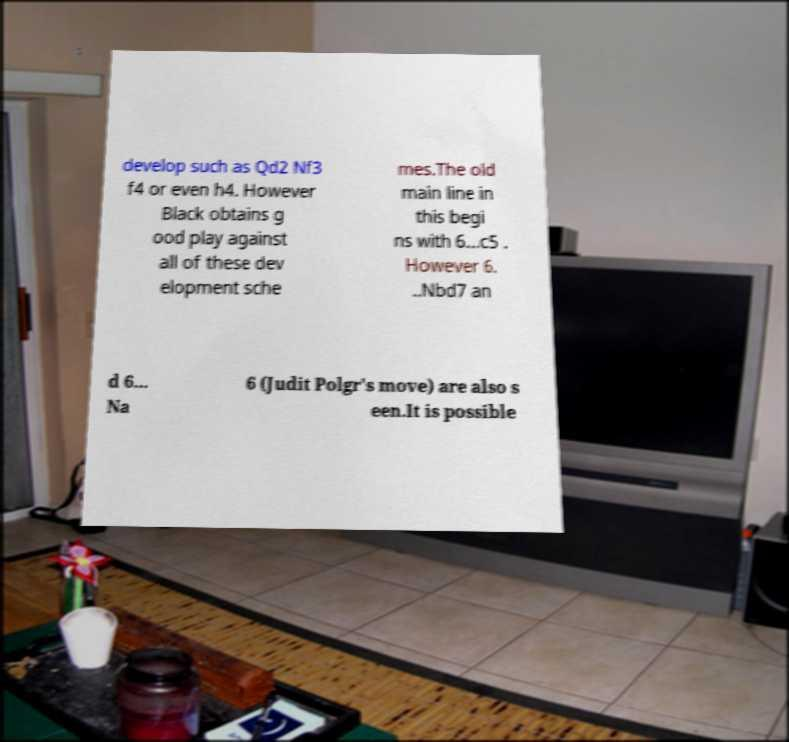Can you read and provide the text displayed in the image?This photo seems to have some interesting text. Can you extract and type it out for me? develop such as Qd2 Nf3 f4 or even h4. However Black obtains g ood play against all of these dev elopment sche mes.The old main line in this begi ns with 6...c5 . However 6. ..Nbd7 an d 6... Na 6 (Judit Polgr's move) are also s een.It is possible 